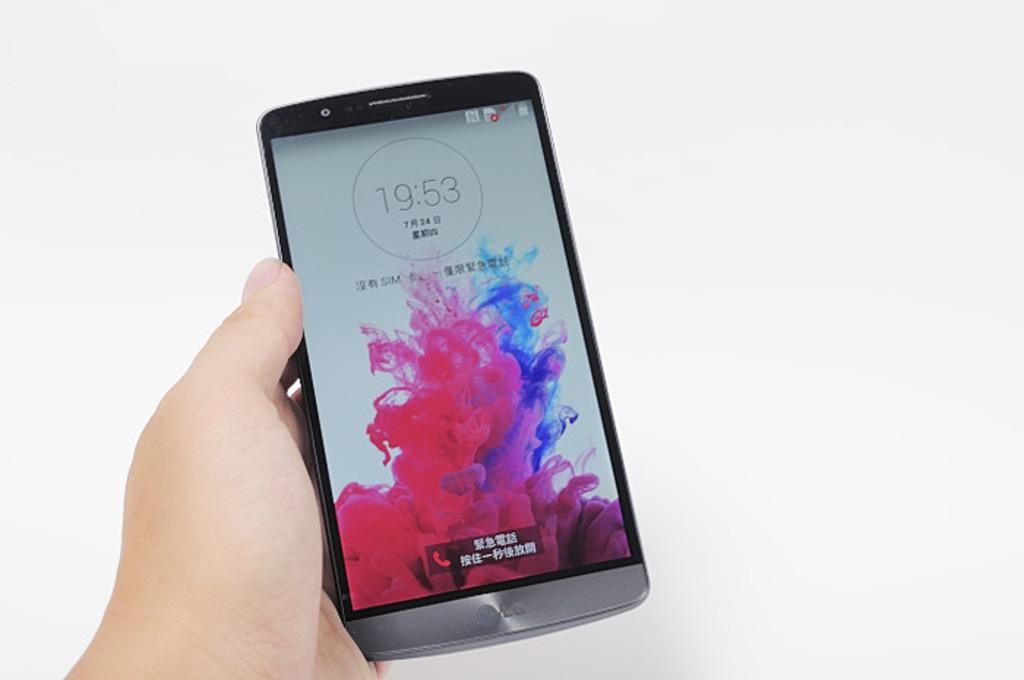What time is it?
Make the answer very short. 19:53. Who makes this phone?
Your answer should be compact. Lg. 